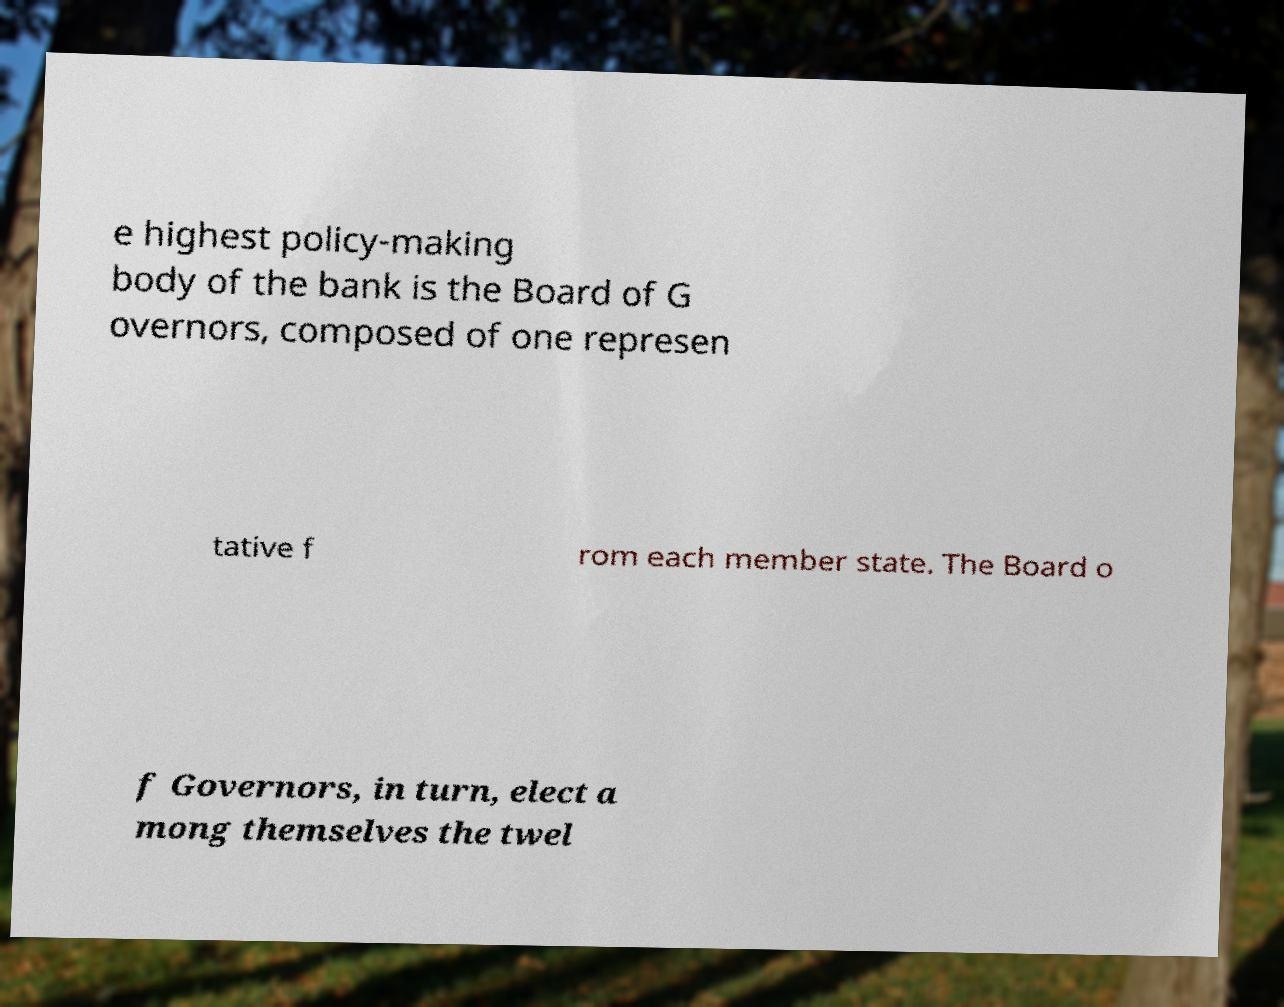What messages or text are displayed in this image? I need them in a readable, typed format. e highest policy-making body of the bank is the Board of G overnors, composed of one represen tative f rom each member state. The Board o f Governors, in turn, elect a mong themselves the twel 